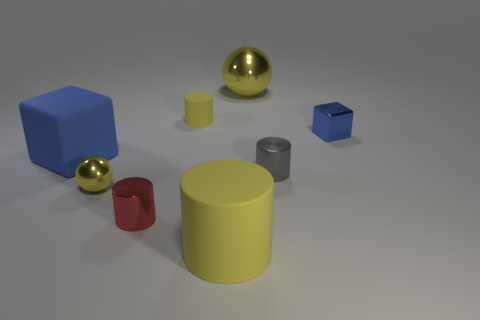There is a ball that is in front of the blue thing that is behind the large blue matte block; what is its material?
Keep it short and to the point. Metal. What shape is the small metallic object that is the same color as the large matte block?
Your answer should be compact. Cube. The yellow matte thing that is the same size as the gray cylinder is what shape?
Make the answer very short. Cylinder. Is the number of cylinders less than the number of tiny matte cylinders?
Keep it short and to the point. No. There is a tiny gray metallic cylinder that is in front of the large blue object; is there a small blue block that is on the left side of it?
Your answer should be very brief. No. What shape is the blue thing that is made of the same material as the large yellow cylinder?
Your answer should be very brief. Cube. Are there any other things that have the same color as the large cylinder?
Ensure brevity in your answer.  Yes. There is a big blue thing that is the same shape as the small blue metallic object; what is its material?
Ensure brevity in your answer.  Rubber. What number of other things are the same size as the red metallic thing?
Offer a very short reply. 4. There is a matte thing that is the same color as the large cylinder; what size is it?
Ensure brevity in your answer.  Small. 